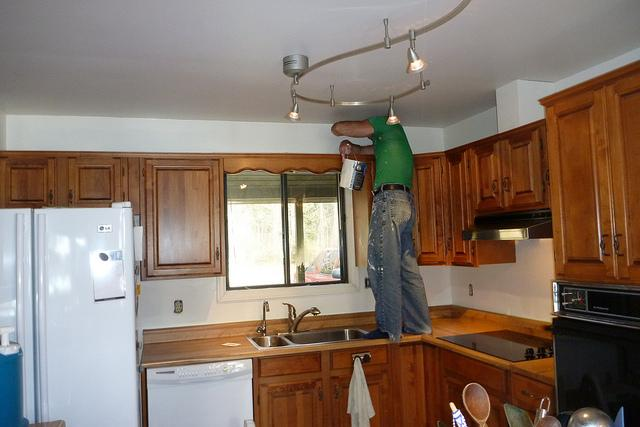Why is the man on the counter?

Choices:
A) to paint
B) to surprise
C) to hide
D) to rest to paint 